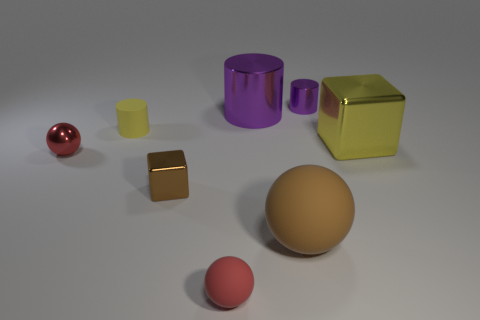Add 1 big matte balls. How many objects exist? 9 Subtract all blocks. How many objects are left? 6 Subtract 2 red spheres. How many objects are left? 6 Subtract all tiny purple shiny objects. Subtract all metal spheres. How many objects are left? 6 Add 4 large purple metallic cylinders. How many large purple metallic cylinders are left? 5 Add 6 purple cylinders. How many purple cylinders exist? 8 